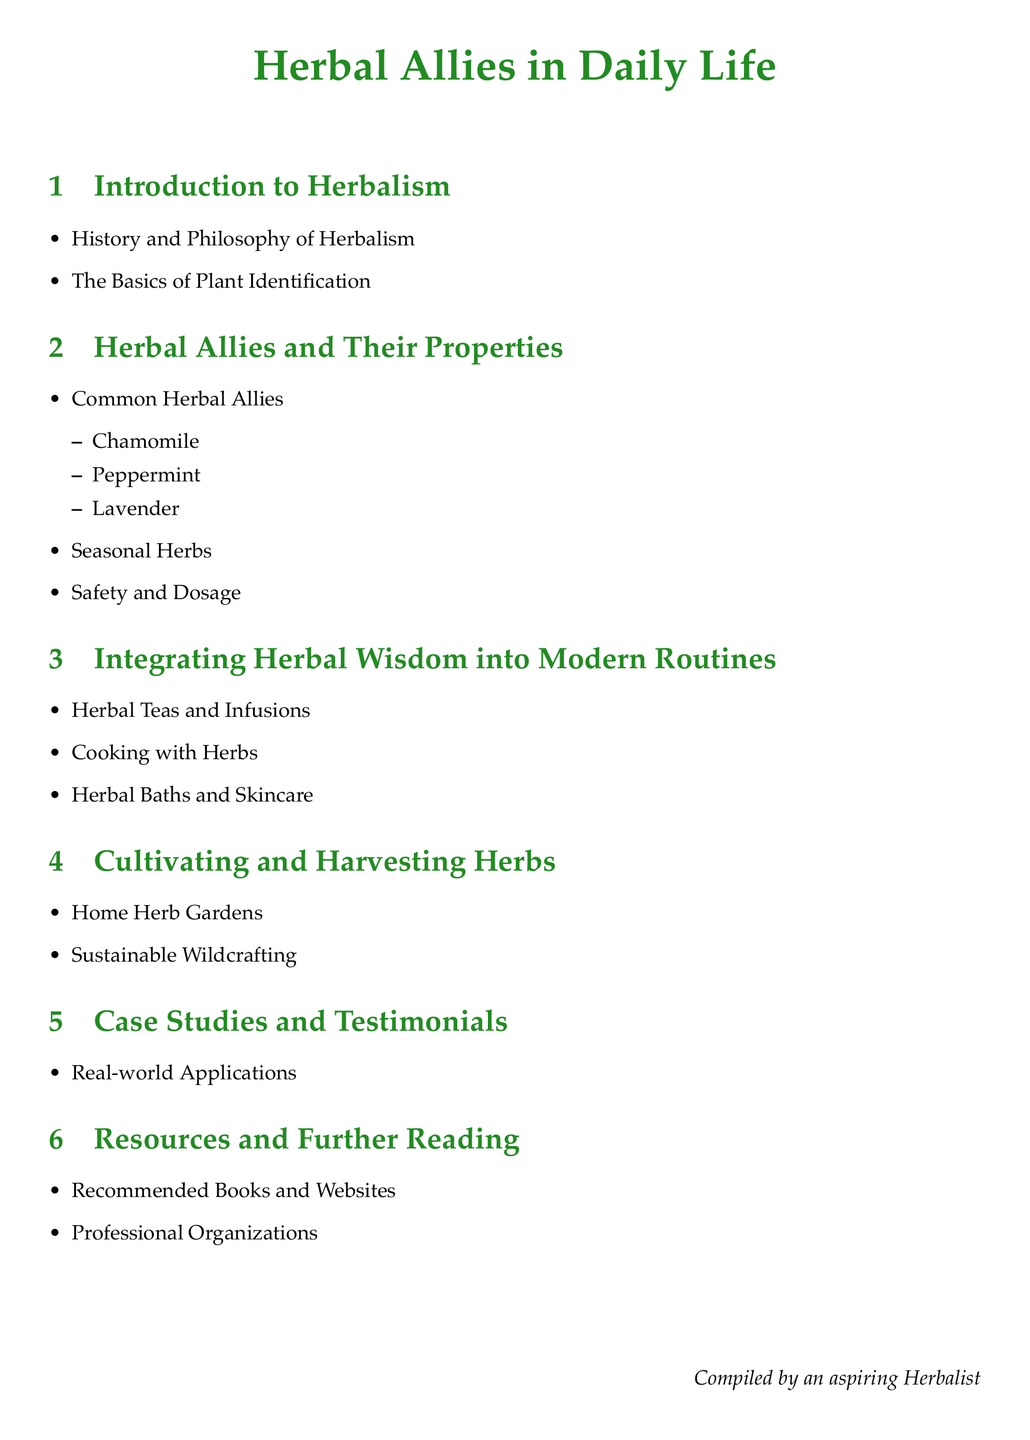What is the first section in the document? The first section listed in the table of contents is "Introduction to Herbalism."
Answer: Introduction to Herbalism How many common herbal allies are mentioned? The document lists three common herbal allies: Chamomile, Peppermint, and Lavender.
Answer: Three What is the focus of the third section? The third section is focused on "Integrating Herbal Wisdom into Modern Routines."
Answer: Integrating Herbal Wisdom into Modern Routines What type of gardening does the document mention? The document mentions "Home Herb Gardens" in the section about cultivating and harvesting herbs.
Answer: Home Herb Gardens What are the two main methods of engaging with herbs mentioned in the cultivating section? The document lists "Home Herb Gardens" and "Sustainable Wildcrafting" as the methods.
Answer: Home Herb Gardens, Sustainable Wildcrafting What is included in the last section of the document? The last section of the document includes resources such as "Recommended Books and Websites" and "Professional Organizations."
Answer: Recommended Books and Websites, Professional Organizations Which herb is specifically listed as an ally? Chamomile is specifically listed as one of the common herbal allies.
Answer: Chamomile What kind of practices are discussed in the section about integrating herbal wisdom? The practices include "Herbal Teas and Infusions," "Cooking with Herbs," and "Herbal Baths and Skincare."
Answer: Herbal Teas and Infusions, Cooking with Herbs, Herbal Baths and Skincare 